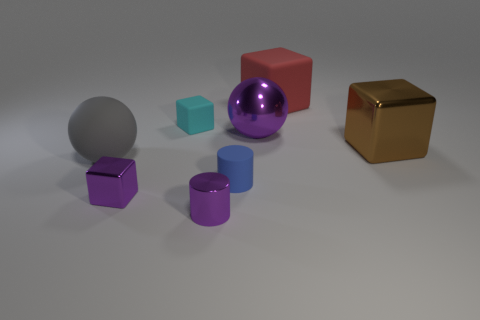Add 1 small blue things. How many objects exist? 9 Subtract all balls. How many objects are left? 6 Subtract 0 brown balls. How many objects are left? 8 Subtract all blue cylinders. Subtract all purple metal balls. How many objects are left? 6 Add 2 purple shiny cubes. How many purple shiny cubes are left? 3 Add 4 red rubber blocks. How many red rubber blocks exist? 5 